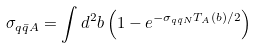Convert formula to latex. <formula><loc_0><loc_0><loc_500><loc_500>\sigma _ { q \bar { q } A } = \int d ^ { 2 } b \left ( 1 - e ^ { - \sigma _ { q \bar { q } N } T _ { A } ( b ) / 2 } \right )</formula> 